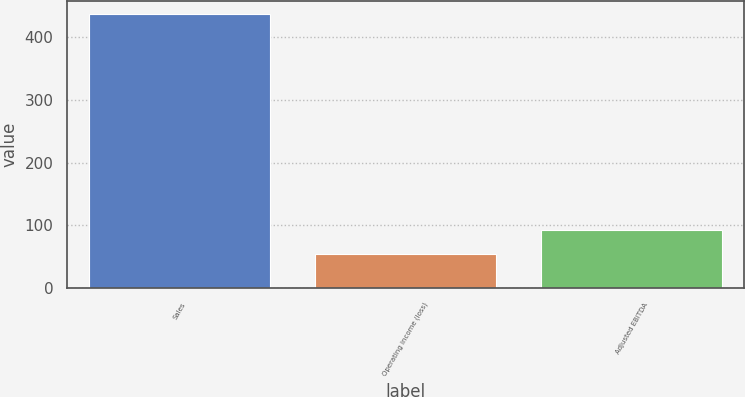Convert chart to OTSL. <chart><loc_0><loc_0><loc_500><loc_500><bar_chart><fcel>Sales<fcel>Operating income (loss)<fcel>Adjusted EBITDA<nl><fcel>436.1<fcel>53.9<fcel>92.12<nl></chart> 